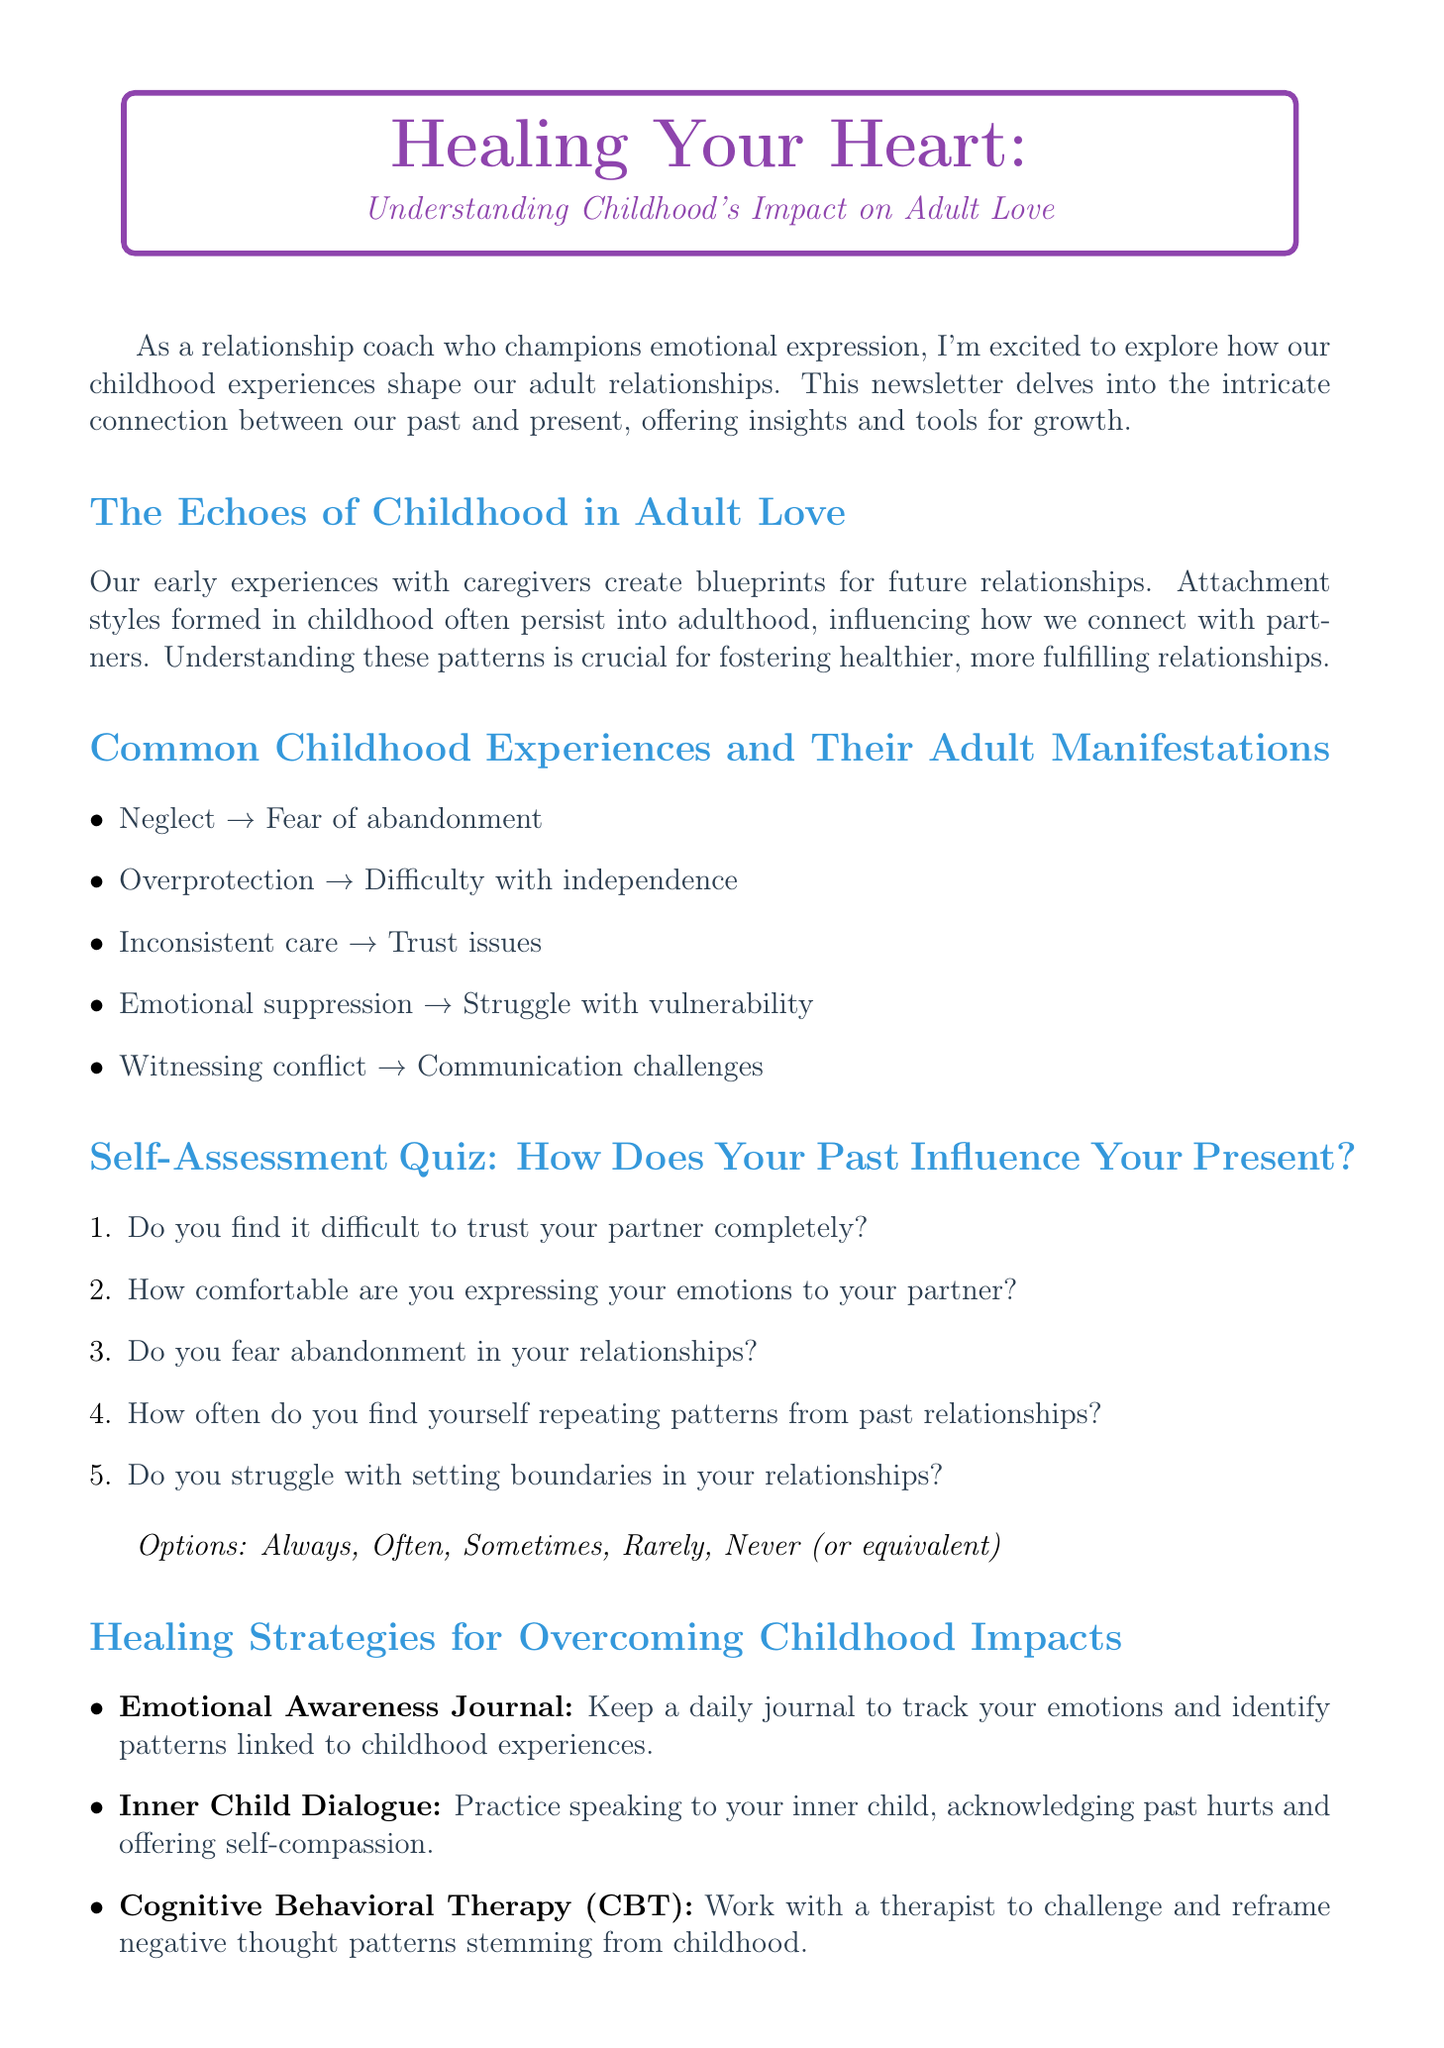what is the title of the newsletter? The title of the newsletter is provided at the beginning of the document.
Answer: Healing Your Heart: Understanding Childhood's Impact on Adult Love what is the name of the expert quoted in the newsletter? The newsletter includes a quote from an expert, which states their name.
Answer: Dr. Brené Brown how many strategies are listed for healing childhood impacts? The section on healing strategies lists multiple strategies for overcoming childhood impacts.
Answer: Five what kind of resources are recommended in the newsletter? The newsletter includes several types of resources for further exploration.
Answer: Book, Podcast, App what is the first question in the self-assessment quiz? The self-assessment quiz has specific questions aimed at personal reflection.
Answer: Do you find it difficult to trust your partner completely? how does emotional suppression affect adult relationships, according to the newsletter? The newsletter links certain childhood experiences with their adult manifestations.
Answer: Struggle with vulnerability what does the Emotional Awareness Journal help track? The document provides a description of the function of the Emotional Awareness Journal.
Answer: Emotions and childhood patterns what is emphasized as important for healing in the newsletter? The content discusses key concepts that are essential for the healing process.
Answer: Vulnerability 